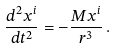Convert formula to latex. <formula><loc_0><loc_0><loc_500><loc_500>\frac { d ^ { 2 } x ^ { i } } { d t ^ { 2 } } = - \frac { M x ^ { i } } { r ^ { 3 } } \, .</formula> 